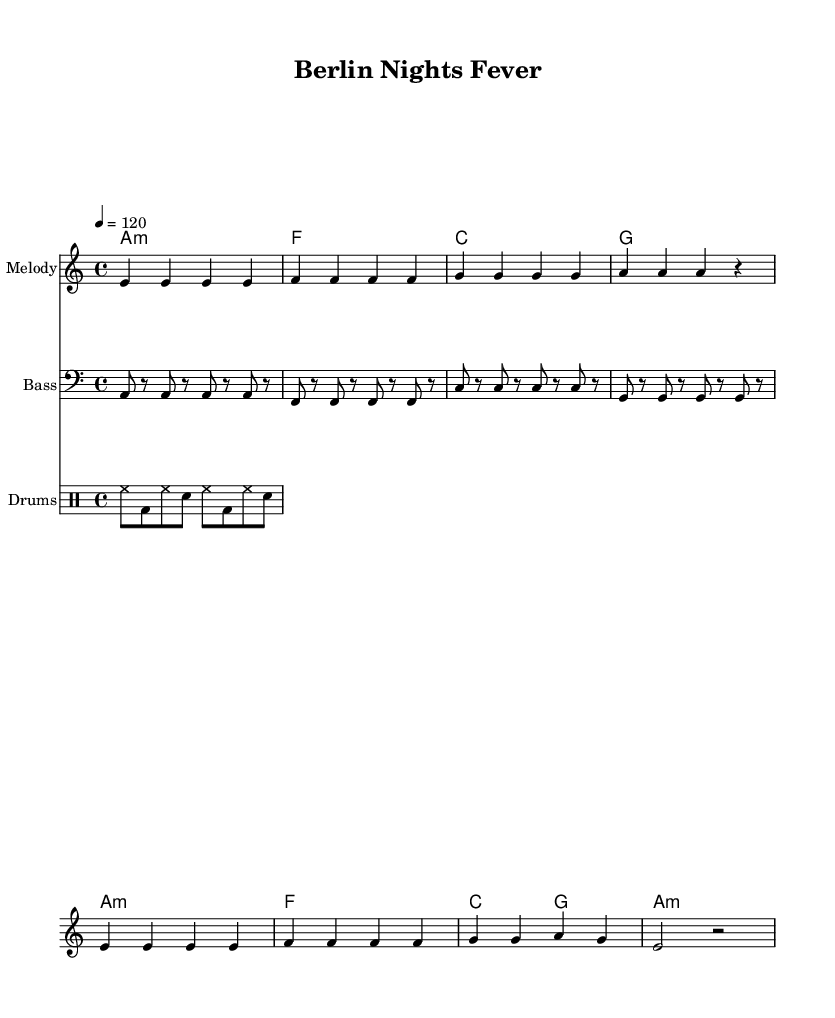What is the key signature of this music? The key signature is indicated at the beginning of the staff and is A minor, which has no sharps or flats.
Answer: A minor What is the time signature of this piece? The time signature is found at the beginning of the music, showing that it is in 4/4 time, meaning there are four beats in each measure.
Answer: 4/4 What is the tempo marking for this music? The tempo is specified in beats per minute at the top of the score, indicating a speed of 120 beats per minute.
Answer: 120 How many measures are in the melody? By counting the vertical lines (bar lines) in the melody section, there are 8 measures total.
Answer: 8 What type of bass clef is used in this piece? The bass clef is specifically a standard bass clef, indicated by the clef symbol at the beginning of the bass staff line.
Answer: Bass clef What is the structure of the chord progression? The chord progression follows a specific sequence: A minor, F major, C major, and G major in succession, which are typical in this disco context.
Answer: A minor, F, C, G What rhythmic pattern is primarily used in the drum section? The drum section features hi-hat, bass, and snare patterns with a consistent repeating rhythm, indicating a classic disco groove.
Answer: Hi-hat, bass, snare 